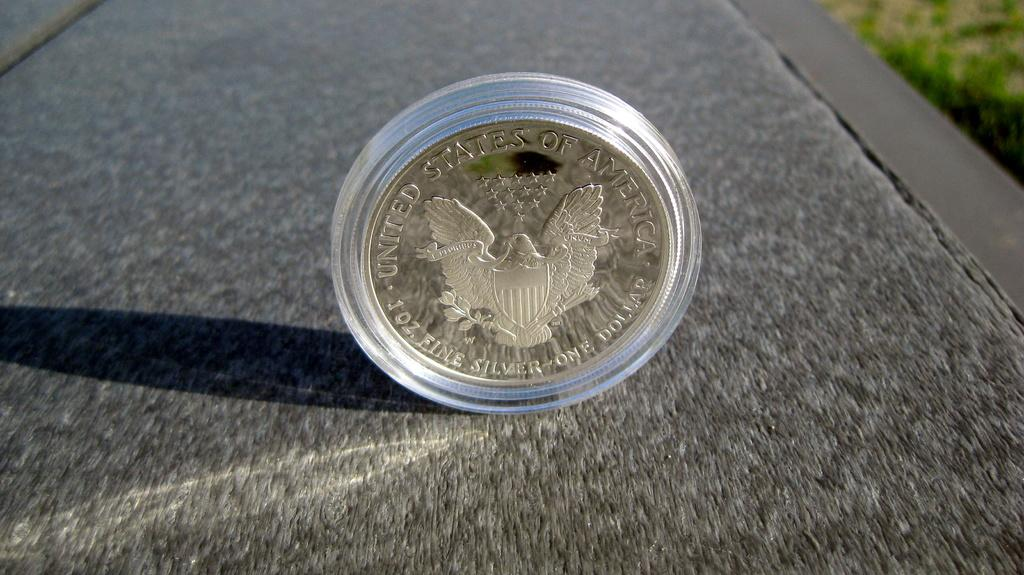<image>
Write a terse but informative summary of the picture. a gold coin standing on its side that says united states of america 